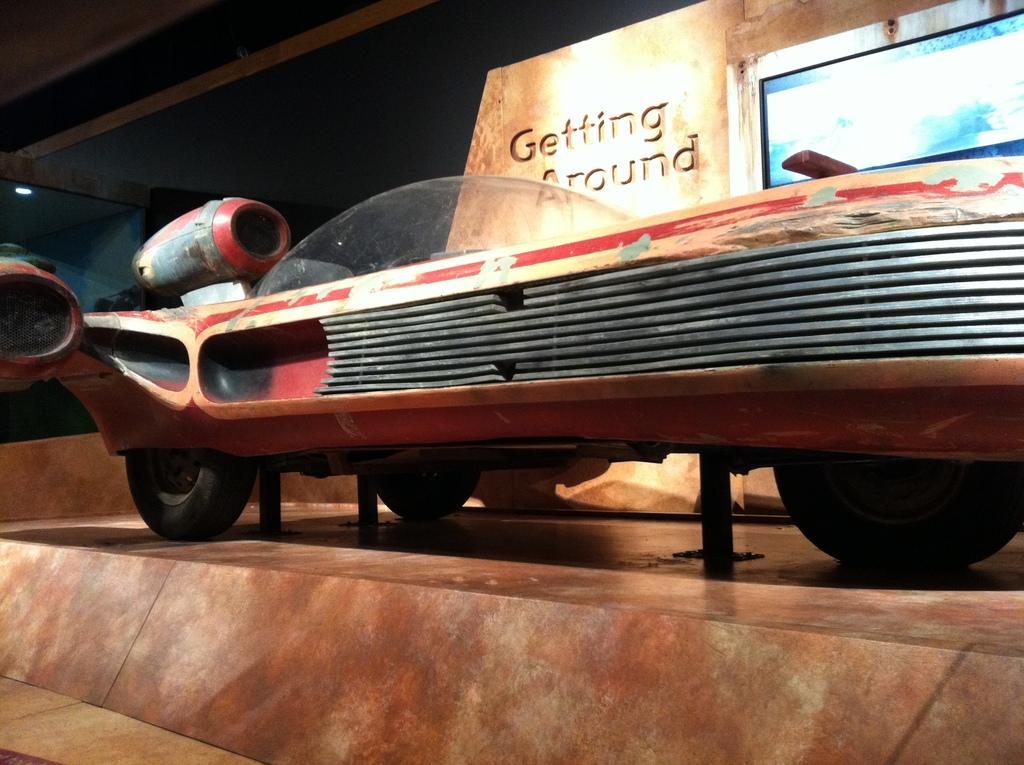Could you give a brief overview of what you see in this image? In this image we can see a vehicle and in the background, it looks like a building, also we can see some text on the wall and a screen. 